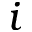<formula> <loc_0><loc_0><loc_500><loc_500>i</formula> 